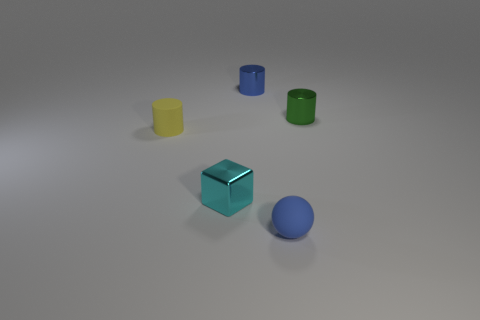Subtract all yellow cylinders. How many cylinders are left? 2 Subtract all green metal cylinders. How many cylinders are left? 2 Add 4 cyan matte objects. How many objects exist? 9 Subtract all green cylinders. Subtract all brown cubes. How many cylinders are left? 2 Subtract all purple balls. How many blue cylinders are left? 1 Subtract all small yellow matte things. Subtract all small cyan objects. How many objects are left? 3 Add 3 yellow objects. How many yellow objects are left? 4 Add 3 small cyan metal blocks. How many small cyan metal blocks exist? 4 Subtract 0 cyan cylinders. How many objects are left? 5 Subtract all cylinders. How many objects are left? 2 